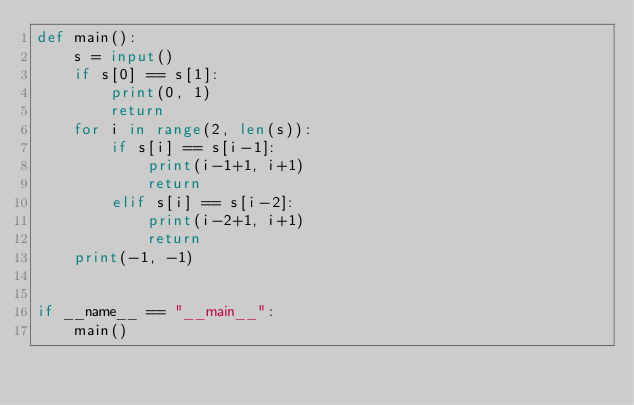Convert code to text. <code><loc_0><loc_0><loc_500><loc_500><_Python_>def main():
    s = input()
    if s[0] == s[1]:
        print(0, 1)
        return
    for i in range(2, len(s)):
        if s[i] == s[i-1]:
            print(i-1+1, i+1)
            return
        elif s[i] == s[i-2]:
            print(i-2+1, i+1)
            return
    print(-1, -1)


if __name__ == "__main__":
    main()
</code> 